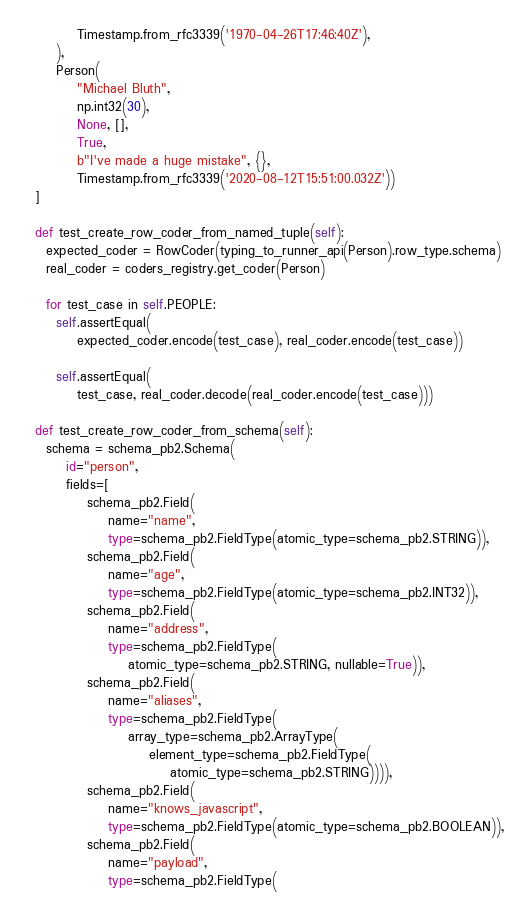<code> <loc_0><loc_0><loc_500><loc_500><_Python_>          Timestamp.from_rfc3339('1970-04-26T17:46:40Z'),
      ),
      Person(
          "Michael Bluth",
          np.int32(30),
          None, [],
          True,
          b"I've made a huge mistake", {},
          Timestamp.from_rfc3339('2020-08-12T15:51:00.032Z'))
  ]

  def test_create_row_coder_from_named_tuple(self):
    expected_coder = RowCoder(typing_to_runner_api(Person).row_type.schema)
    real_coder = coders_registry.get_coder(Person)

    for test_case in self.PEOPLE:
      self.assertEqual(
          expected_coder.encode(test_case), real_coder.encode(test_case))

      self.assertEqual(
          test_case, real_coder.decode(real_coder.encode(test_case)))

  def test_create_row_coder_from_schema(self):
    schema = schema_pb2.Schema(
        id="person",
        fields=[
            schema_pb2.Field(
                name="name",
                type=schema_pb2.FieldType(atomic_type=schema_pb2.STRING)),
            schema_pb2.Field(
                name="age",
                type=schema_pb2.FieldType(atomic_type=schema_pb2.INT32)),
            schema_pb2.Field(
                name="address",
                type=schema_pb2.FieldType(
                    atomic_type=schema_pb2.STRING, nullable=True)),
            schema_pb2.Field(
                name="aliases",
                type=schema_pb2.FieldType(
                    array_type=schema_pb2.ArrayType(
                        element_type=schema_pb2.FieldType(
                            atomic_type=schema_pb2.STRING)))),
            schema_pb2.Field(
                name="knows_javascript",
                type=schema_pb2.FieldType(atomic_type=schema_pb2.BOOLEAN)),
            schema_pb2.Field(
                name="payload",
                type=schema_pb2.FieldType(</code> 